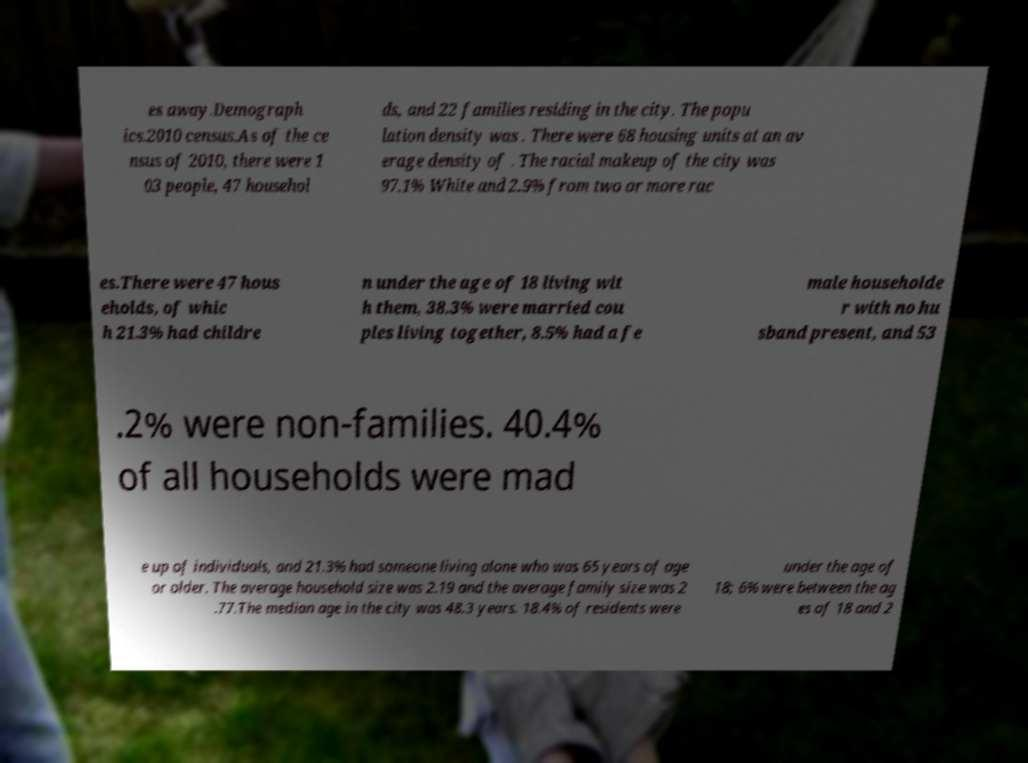Please identify and transcribe the text found in this image. es away.Demograph ics.2010 census.As of the ce nsus of 2010, there were 1 03 people, 47 househol ds, and 22 families residing in the city. The popu lation density was . There were 68 housing units at an av erage density of . The racial makeup of the city was 97.1% White and 2.9% from two or more rac es.There were 47 hous eholds, of whic h 21.3% had childre n under the age of 18 living wit h them, 38.3% were married cou ples living together, 8.5% had a fe male householde r with no hu sband present, and 53 .2% were non-families. 40.4% of all households were mad e up of individuals, and 21.3% had someone living alone who was 65 years of age or older. The average household size was 2.19 and the average family size was 2 .77.The median age in the city was 48.3 years. 18.4% of residents were under the age of 18; 6% were between the ag es of 18 and 2 